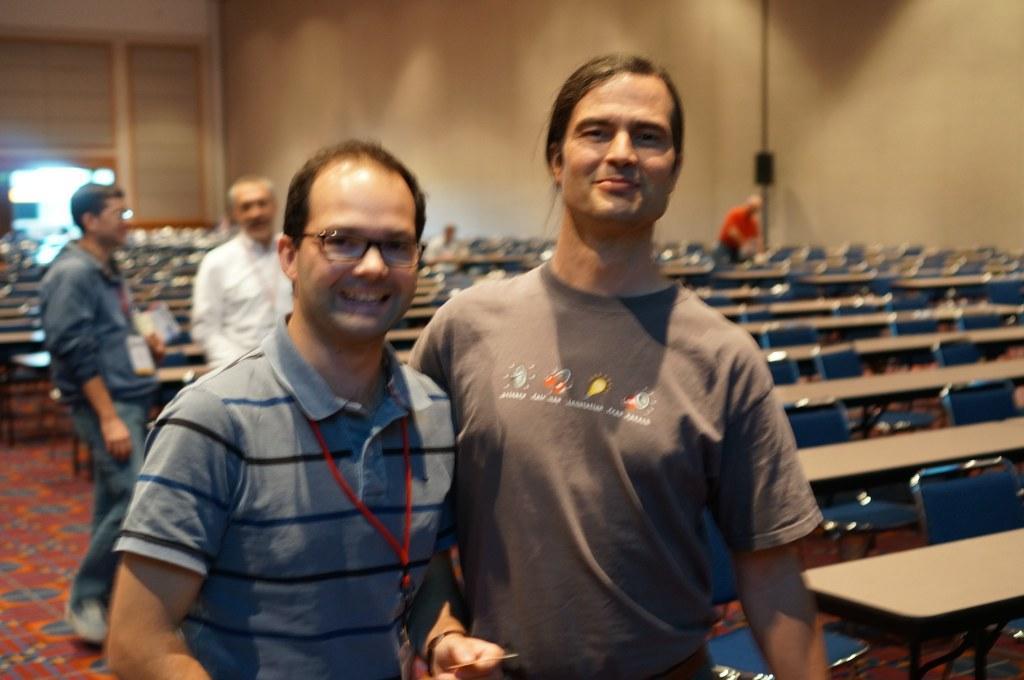In one or two sentences, can you explain what this image depicts? In the picture I can see persons standing, there are some benches, chairs and in the background there is a wall. 